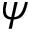Convert formula to latex. <formula><loc_0><loc_0><loc_500><loc_500>\boldsymbol \psi</formula> 